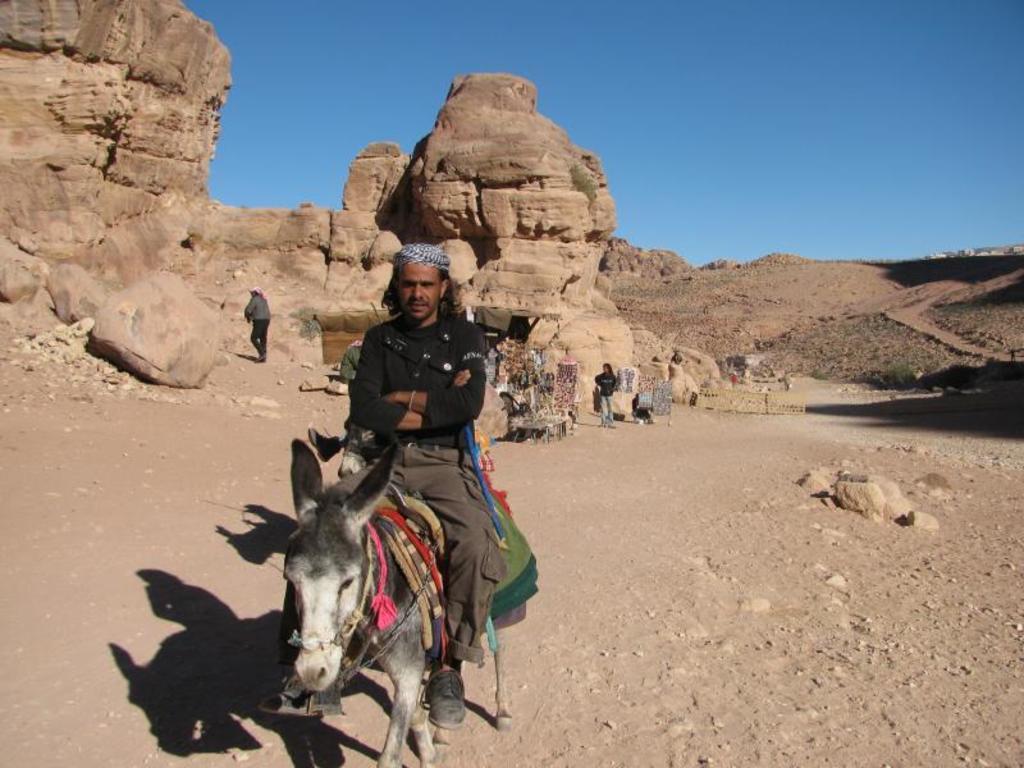In one or two sentences, can you explain what this image depicts? In the image there is a sitting on donkey and behind there are few persons standing, this is dessert with sand dunes in the background and above its sky. 